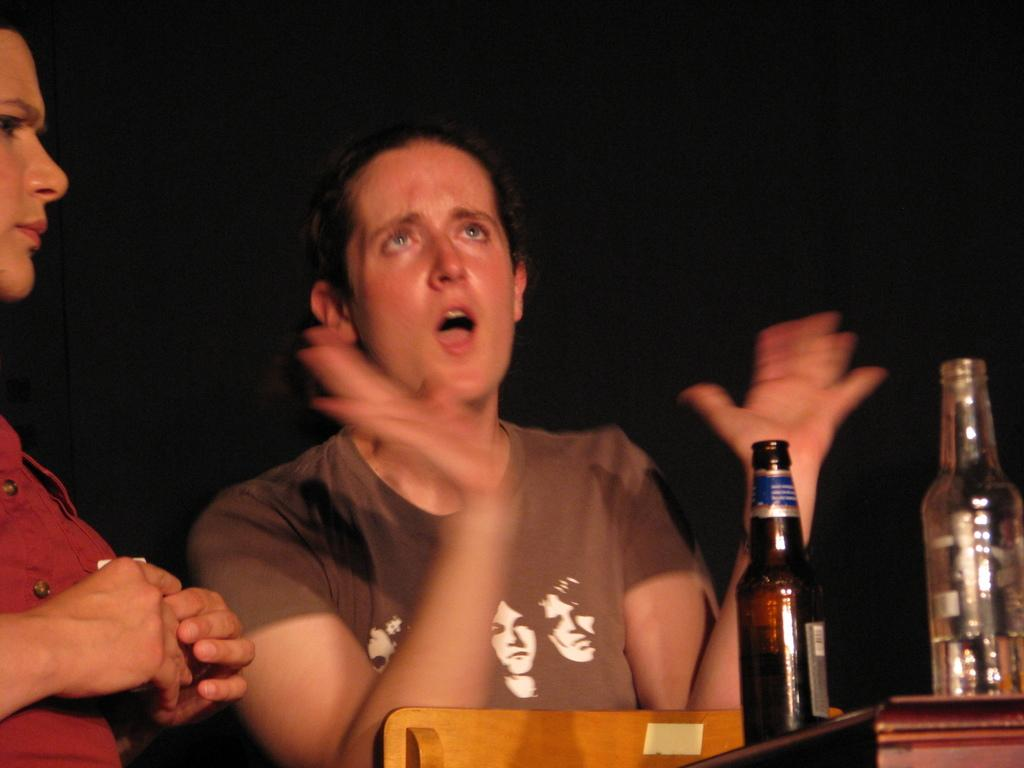How many people are in the image? There are two persons in the image. What is present in the image besides the people? There is a table in the image. What can be seen on the table? There are two bottles on the table. What type of haircut does the person on the left have in the image? There is no information about haircuts in the image, as it only shows two persons, a table, and two bottles. 